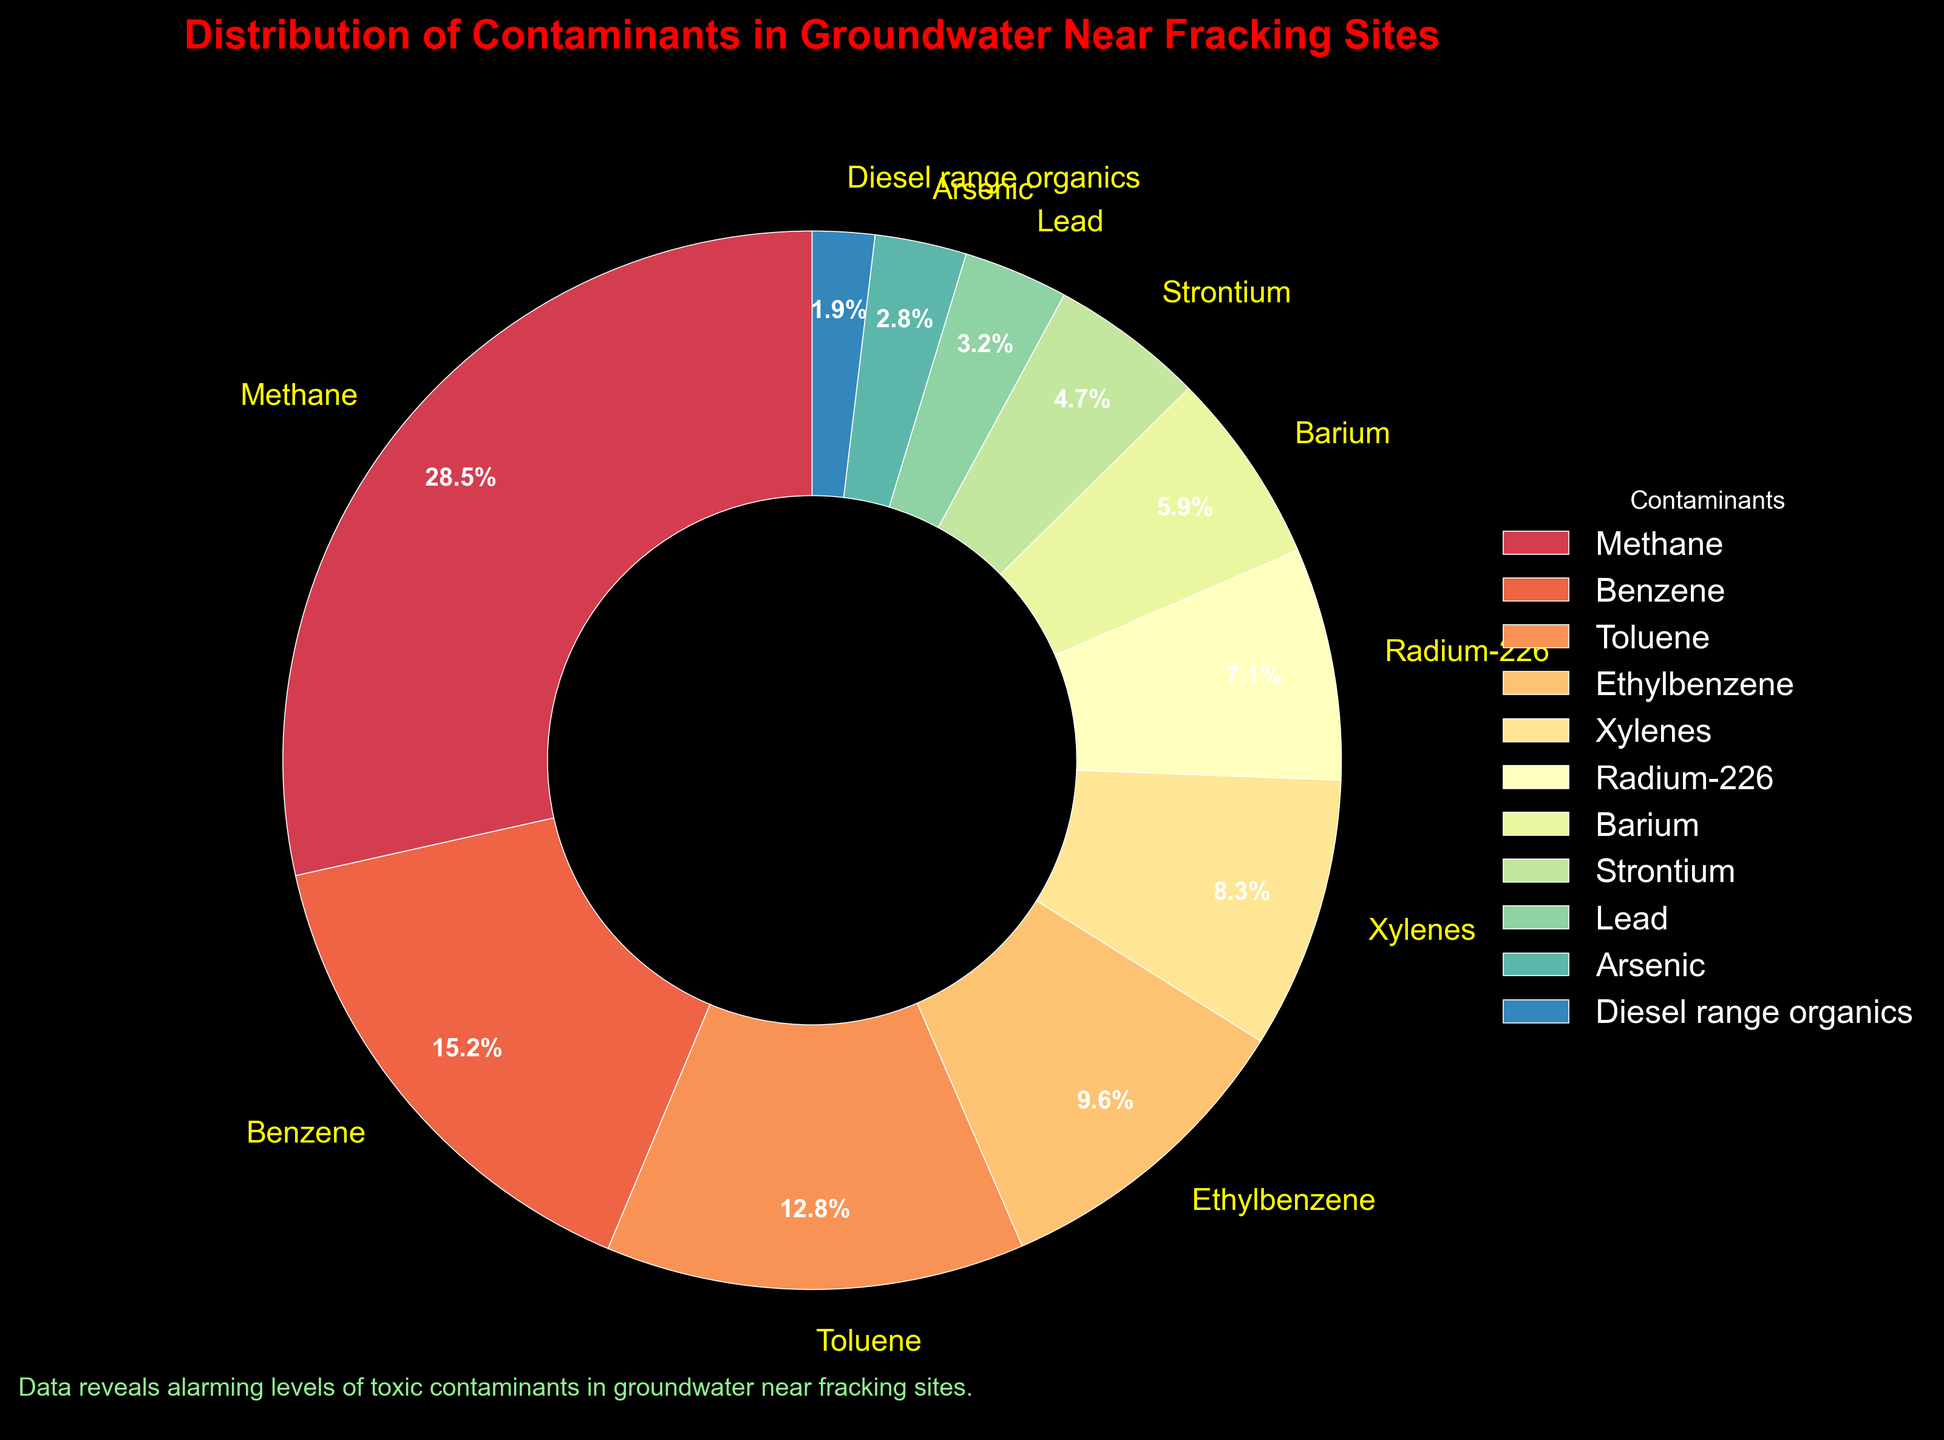Which contaminant has the highest percentage? The pie chart shows different contaminants with their respective percentages. Methane has the largest section of the pie chart, indicating it has the highest percentage.
Answer: Methane What is the combined percentage of Benzene and Toluene? Referring to the chart, Benzene has 15.2% and Toluene has 12.8%. Adding these percentages gives 15.2 + 12.8 = 28.0%.
Answer: 28.0% Which contaminant has the smallest percentage? The pie chart indicates the smallest slice corresponds to Diesel range organics, with a percentage of 1.9%.
Answer: Diesel range organics How does the percentage of Lead compare with Arsenic? Observing the pie chart, Lead has a percentage of 3.2% while Arsenic has a percentage of 2.8%. Since 3.2% is greater than 2.8%, Lead has a higher percentage than Arsenic.
Answer: Lead has a higher percentage What is the average percentage of Ethylbenzene, Xylenes, and Radium-226? The chart shows Ethylbenzene with 9.6%, Xylenes with 8.3%, and Radium-226 with 7.1%. Adding these percentages and dividing by 3 gives (9.6 + 8.3 + 7.1) / 3 = 25 / 3 ≈ 8.33%.
Answer: 8.33% What is the difference between the percentage of Methane and Barium? From the chart, Methane has 28.5% and Barium has 5.9%. Subtracting these gives 28.5 - 5.9 = 22.6%.
Answer: 22.6% Which two contaminants together make up more than 40% of the total? Examining the pie chart, Methane (28.5%) and Benzene (15.2%) together make up 28.5 + 15.2 = 43.7%, which is more than 40%.
Answer: Methane and Benzene How many contaminants have percentages greater than 10%? From the chart, the contaminants with percentages greater than 10% are Methane (28.5%), Benzene (15.2%), and Toluene (12.8%). Hence, there are three contaminants.
Answer: 3 If all the contaminants' percentages are summed up, what should the total be? Since the percentages in a pie chart represent 100% of the total data, adding all the contaminants will always yield 100%.
Answer: 100% 